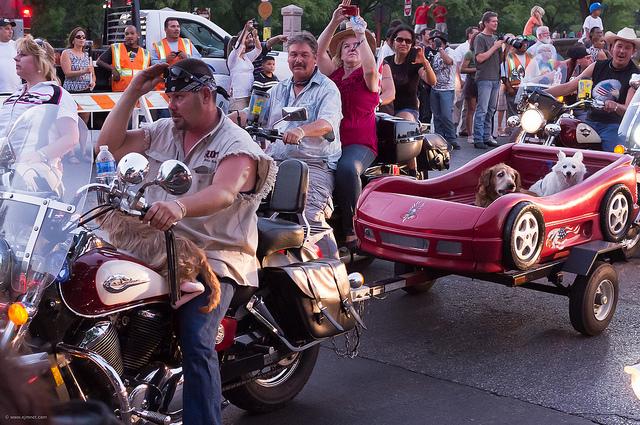What is in the cart?
Answer briefly. Dogs. What are these people riding?
Concise answer only. Motorcycles. How many people are in the crowd?
Short answer required. 20. What type of motorcycle is at the head of the parade?
Quick response, please. Harley. 